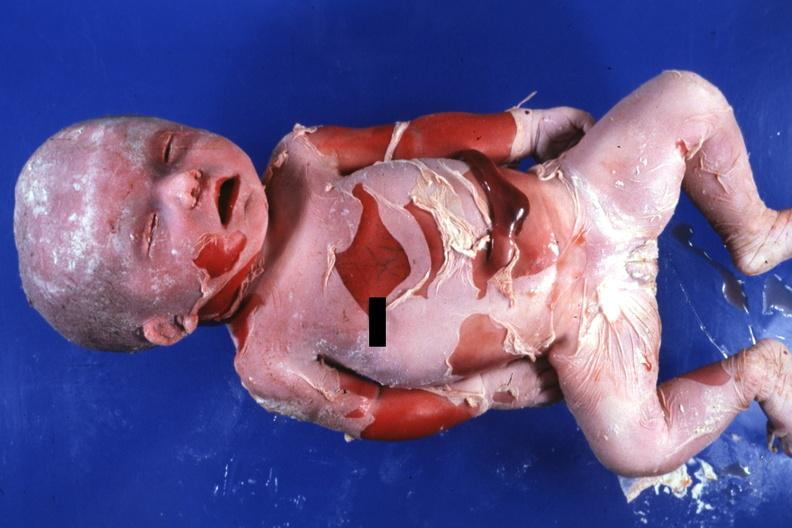does this image show natural color advanced typical?
Answer the question using a single word or phrase. Yes 